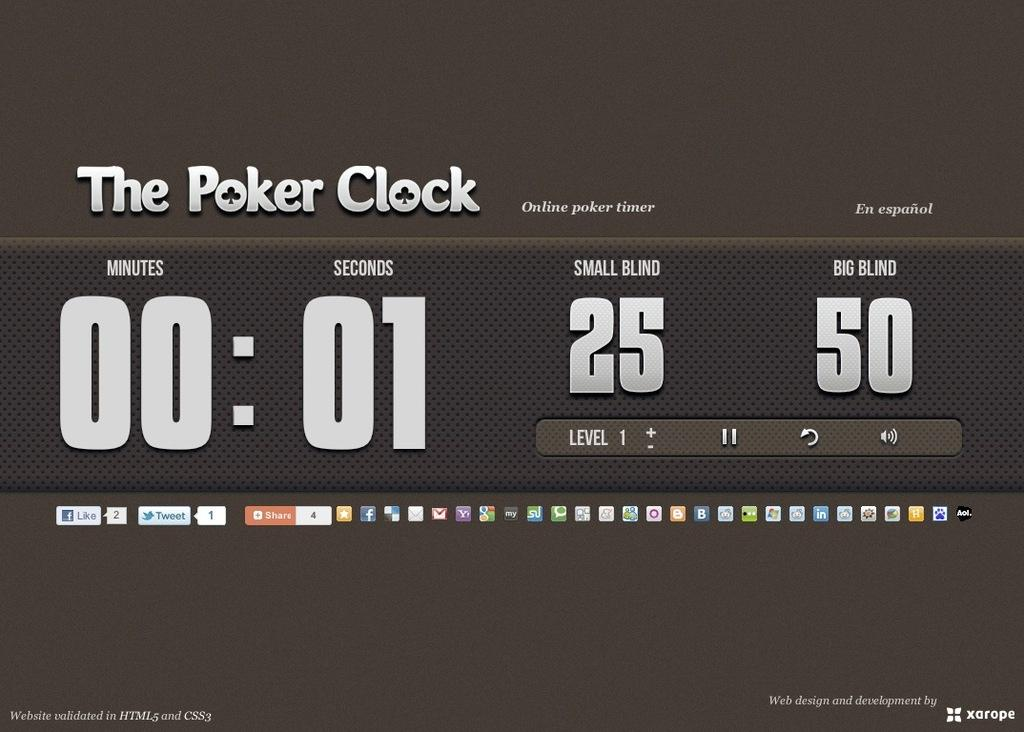<image>
Provide a brief description of the given image. A screen showing a web page called The Poker Clock shows an online poker timer. 